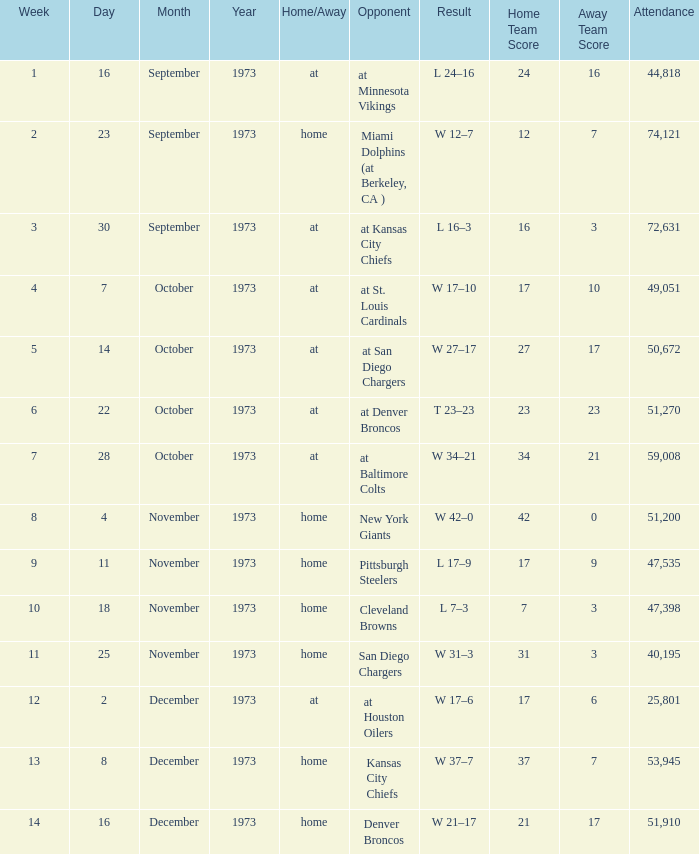What happens following the completion of week 13? W 21–17. 